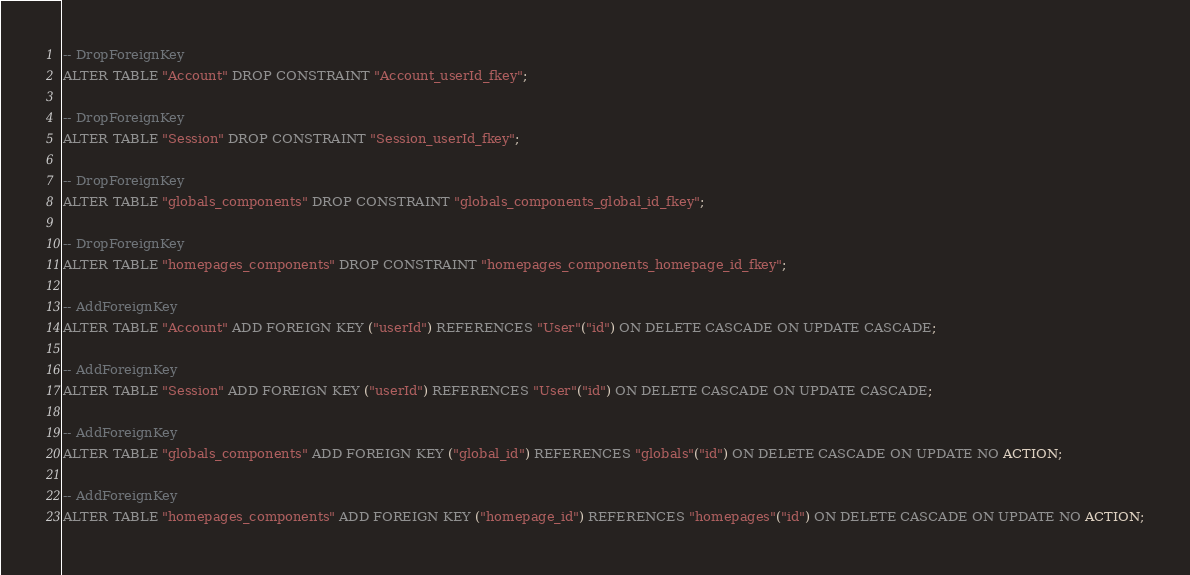Convert code to text. <code><loc_0><loc_0><loc_500><loc_500><_SQL_>-- DropForeignKey
ALTER TABLE "Account" DROP CONSTRAINT "Account_userId_fkey";

-- DropForeignKey
ALTER TABLE "Session" DROP CONSTRAINT "Session_userId_fkey";

-- DropForeignKey
ALTER TABLE "globals_components" DROP CONSTRAINT "globals_components_global_id_fkey";

-- DropForeignKey
ALTER TABLE "homepages_components" DROP CONSTRAINT "homepages_components_homepage_id_fkey";

-- AddForeignKey
ALTER TABLE "Account" ADD FOREIGN KEY ("userId") REFERENCES "User"("id") ON DELETE CASCADE ON UPDATE CASCADE;

-- AddForeignKey
ALTER TABLE "Session" ADD FOREIGN KEY ("userId") REFERENCES "User"("id") ON DELETE CASCADE ON UPDATE CASCADE;

-- AddForeignKey
ALTER TABLE "globals_components" ADD FOREIGN KEY ("global_id") REFERENCES "globals"("id") ON DELETE CASCADE ON UPDATE NO ACTION;

-- AddForeignKey
ALTER TABLE "homepages_components" ADD FOREIGN KEY ("homepage_id") REFERENCES "homepages"("id") ON DELETE CASCADE ON UPDATE NO ACTION;
</code> 